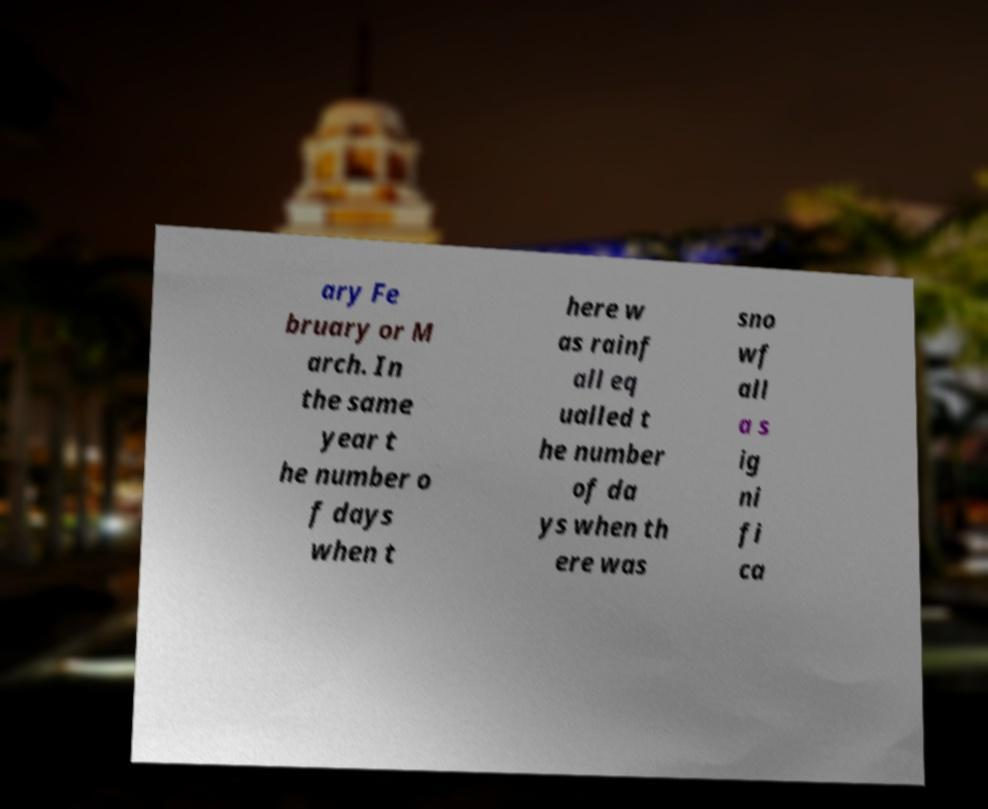Could you assist in decoding the text presented in this image and type it out clearly? ary Fe bruary or M arch. In the same year t he number o f days when t here w as rainf all eq ualled t he number of da ys when th ere was sno wf all a s ig ni fi ca 